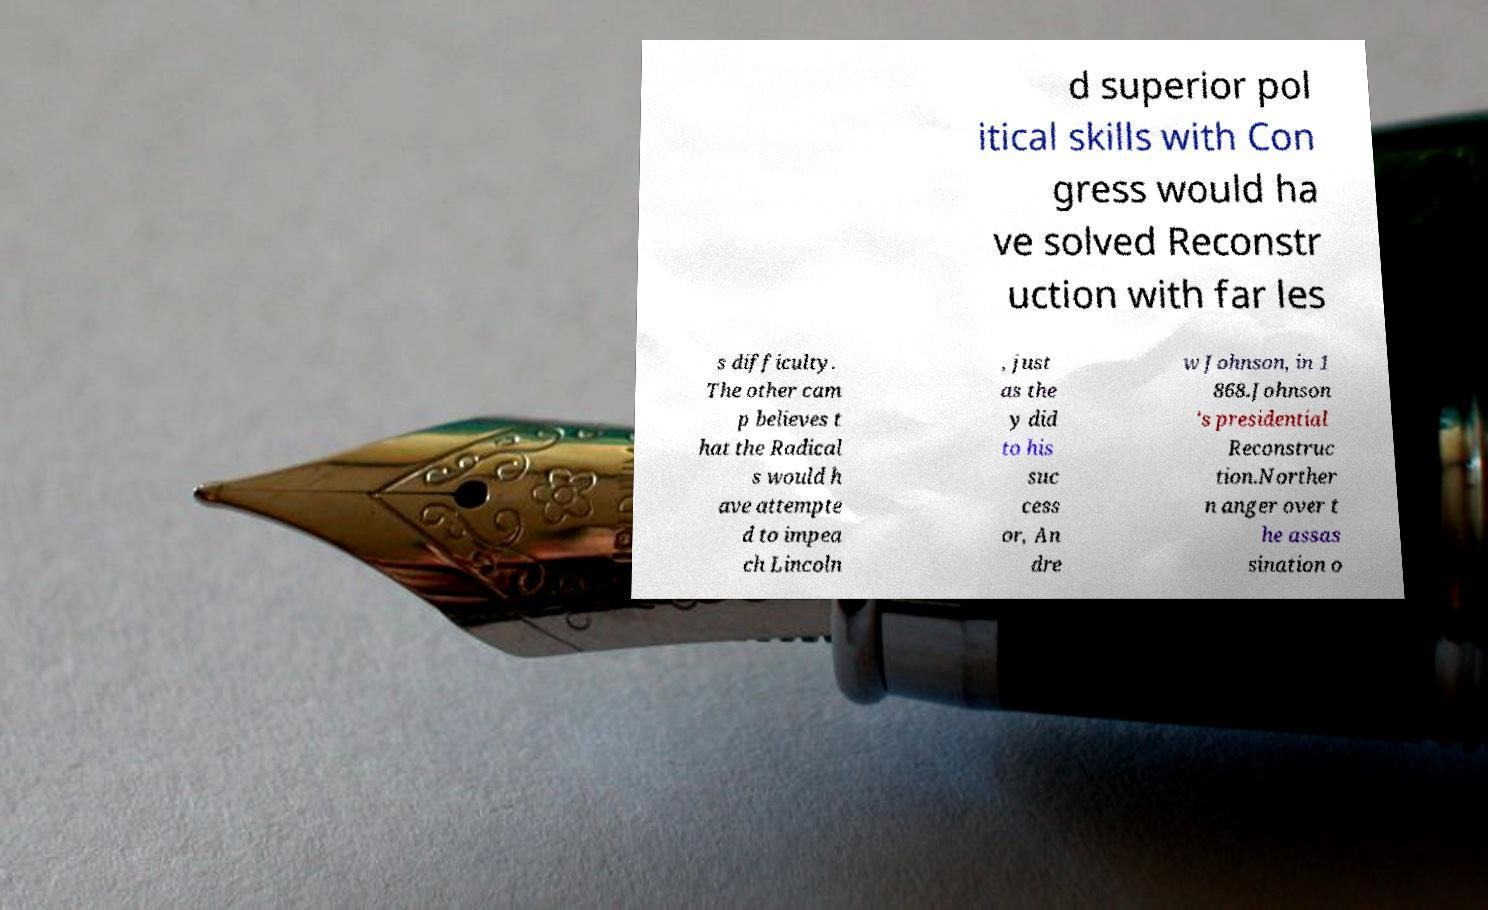Can you read and provide the text displayed in the image?This photo seems to have some interesting text. Can you extract and type it out for me? d superior pol itical skills with Con gress would ha ve solved Reconstr uction with far les s difficulty. The other cam p believes t hat the Radical s would h ave attempte d to impea ch Lincoln , just as the y did to his suc cess or, An dre w Johnson, in 1 868.Johnson 's presidential Reconstruc tion.Norther n anger over t he assas sination o 